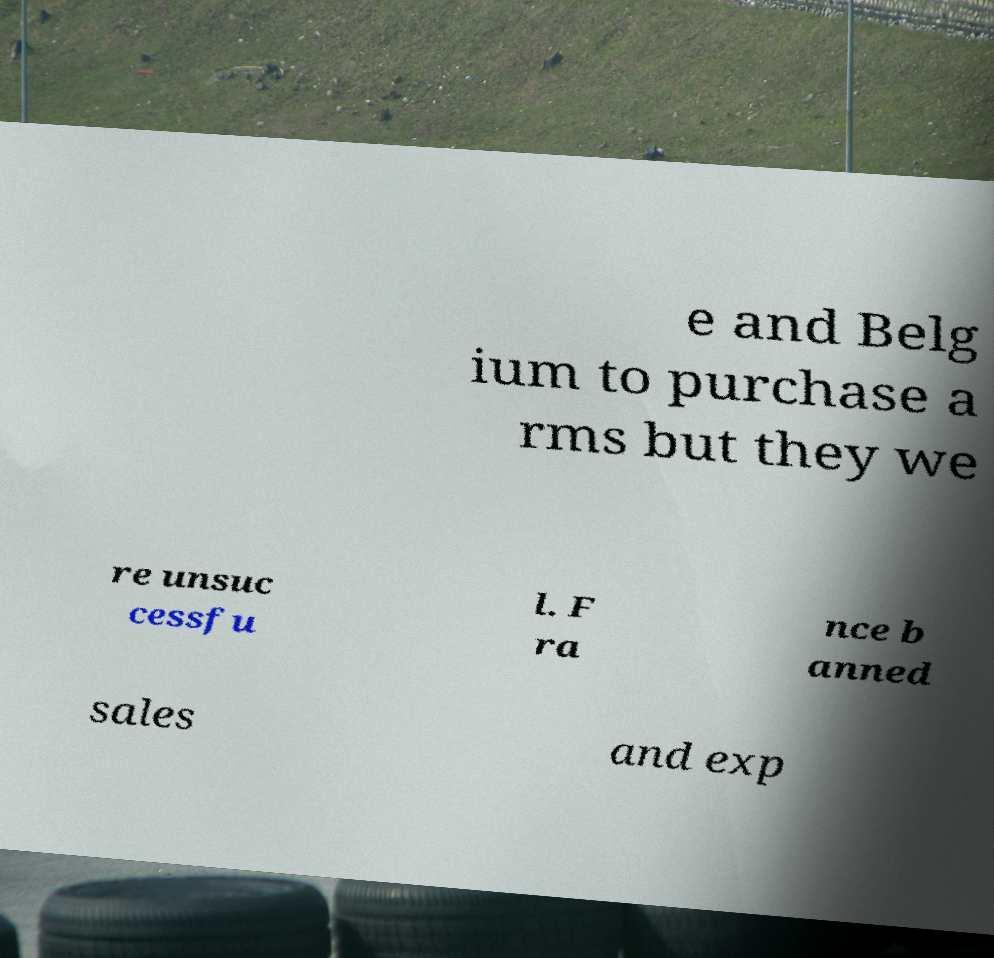Could you assist in decoding the text presented in this image and type it out clearly? e and Belg ium to purchase a rms but they we re unsuc cessfu l. F ra nce b anned sales and exp 